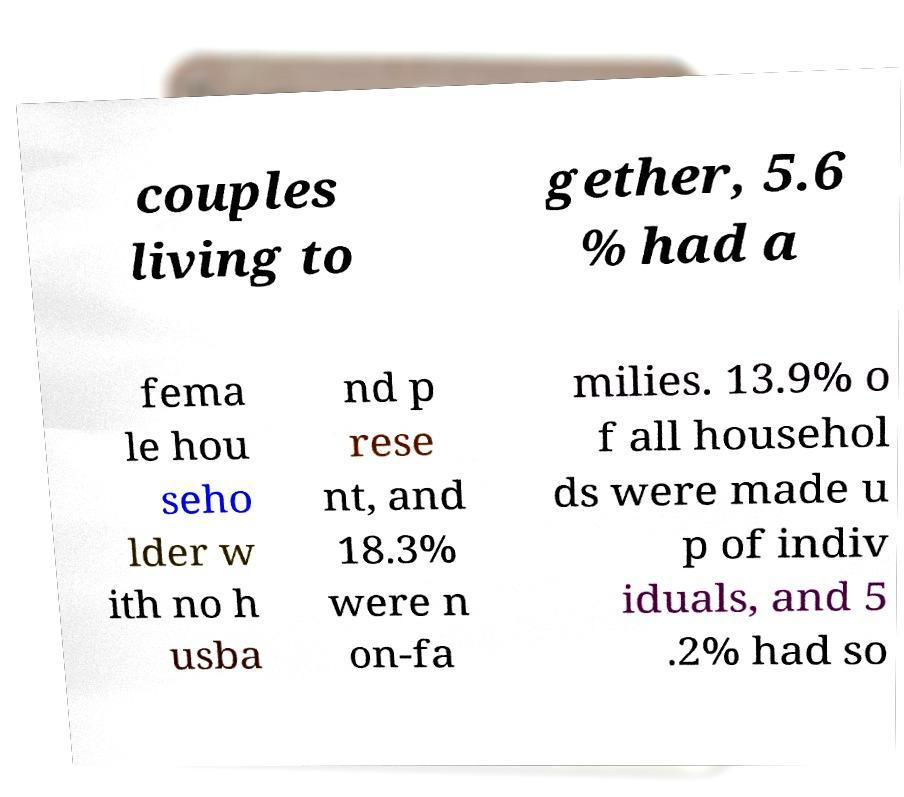Please read and relay the text visible in this image. What does it say? couples living to gether, 5.6 % had a fema le hou seho lder w ith no h usba nd p rese nt, and 18.3% were n on-fa milies. 13.9% o f all househol ds were made u p of indiv iduals, and 5 .2% had so 